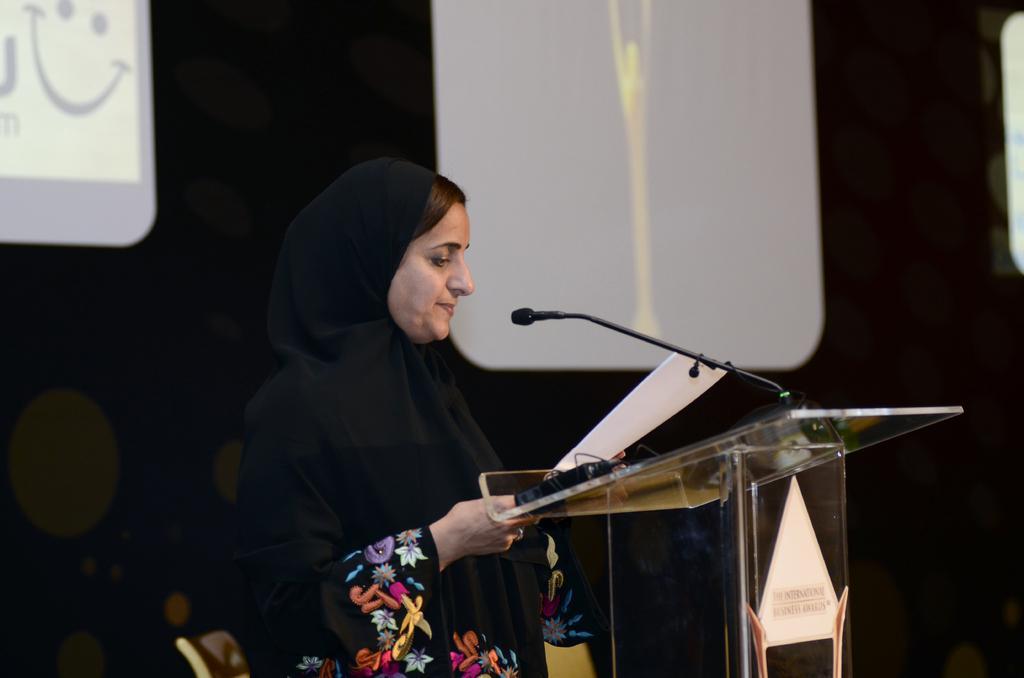Could you give a brief overview of what you see in this image? In this image there is a person holding a paper and standing near the podium , there is a mike, chair, and in the background there is screen. 